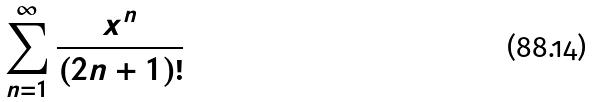Convert formula to latex. <formula><loc_0><loc_0><loc_500><loc_500>\sum _ { n = 1 } ^ { \infty } \frac { x ^ { n } } { ( 2 n + 1 ) ! }</formula> 